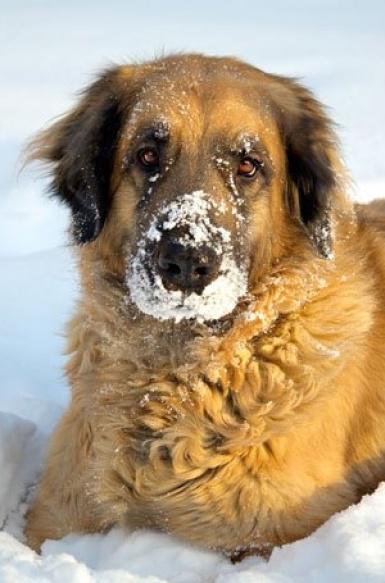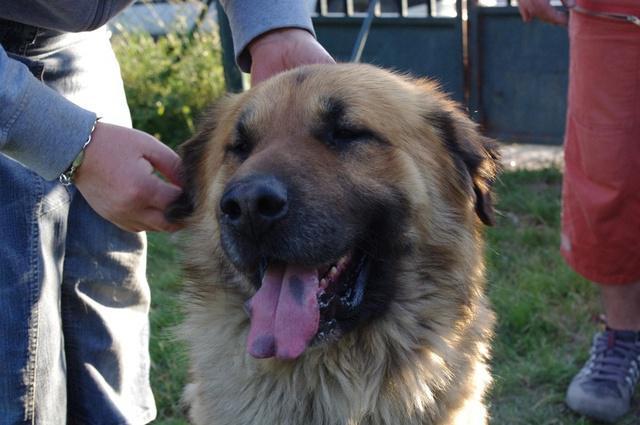The first image is the image on the left, the second image is the image on the right. Evaluate the accuracy of this statement regarding the images: "A trophy stands in the grass next to a dog in one image.". Is it true? Answer yes or no. No. The first image is the image on the left, the second image is the image on the right. Examine the images to the left and right. Is the description "In one of the images there is a large dog next to a trophy." accurate? Answer yes or no. No. 